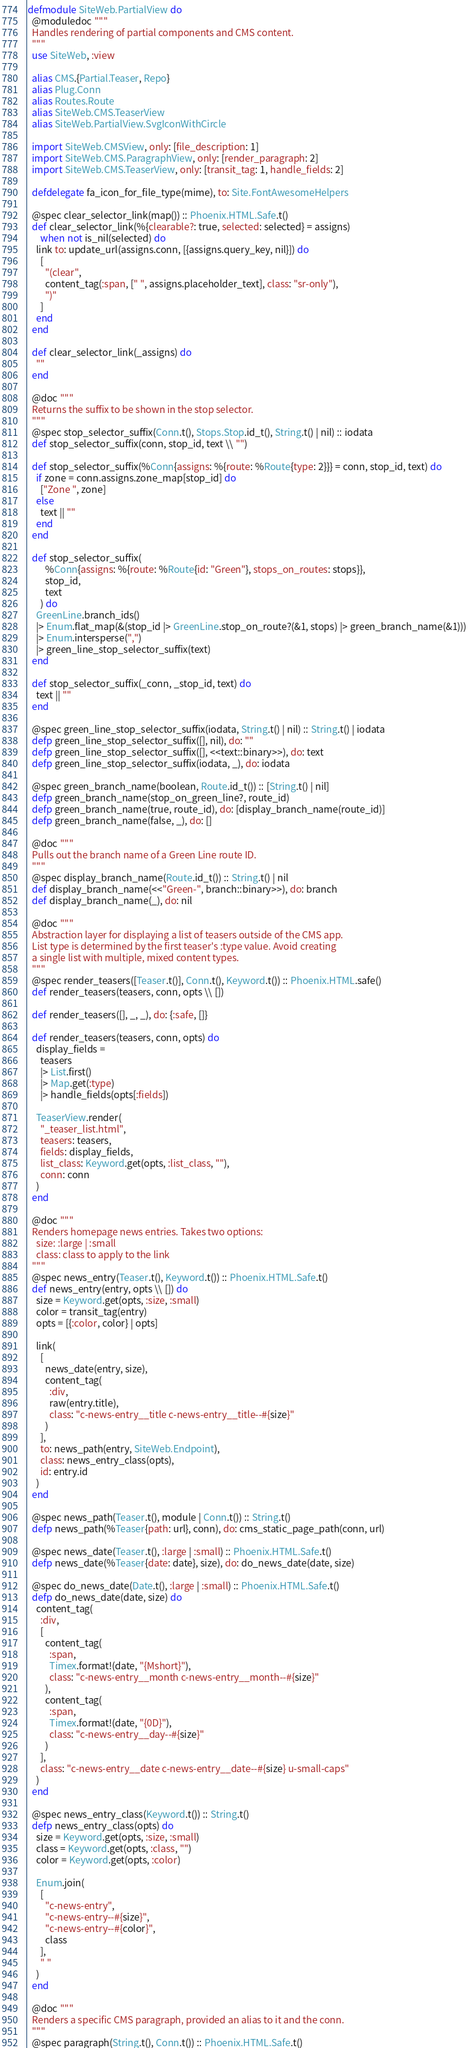<code> <loc_0><loc_0><loc_500><loc_500><_Elixir_>defmodule SiteWeb.PartialView do
  @moduledoc """
  Handles rendering of partial components and CMS content.
  """
  use SiteWeb, :view

  alias CMS.{Partial.Teaser, Repo}
  alias Plug.Conn
  alias Routes.Route
  alias SiteWeb.CMS.TeaserView
  alias SiteWeb.PartialView.SvgIconWithCircle

  import SiteWeb.CMSView, only: [file_description: 1]
  import SiteWeb.CMS.ParagraphView, only: [render_paragraph: 2]
  import SiteWeb.CMS.TeaserView, only: [transit_tag: 1, handle_fields: 2]

  defdelegate fa_icon_for_file_type(mime), to: Site.FontAwesomeHelpers

  @spec clear_selector_link(map()) :: Phoenix.HTML.Safe.t()
  def clear_selector_link(%{clearable?: true, selected: selected} = assigns)
      when not is_nil(selected) do
    link to: update_url(assigns.conn, [{assigns.query_key, nil}]) do
      [
        "(clear",
        content_tag(:span, [" ", assigns.placeholder_text], class: "sr-only"),
        ")"
      ]
    end
  end

  def clear_selector_link(_assigns) do
    ""
  end

  @doc """
  Returns the suffix to be shown in the stop selector.
  """
  @spec stop_selector_suffix(Conn.t(), Stops.Stop.id_t(), String.t() | nil) :: iodata
  def stop_selector_suffix(conn, stop_id, text \\ "")

  def stop_selector_suffix(%Conn{assigns: %{route: %Route{type: 2}}} = conn, stop_id, text) do
    if zone = conn.assigns.zone_map[stop_id] do
      ["Zone ", zone]
    else
      text || ""
    end
  end

  def stop_selector_suffix(
        %Conn{assigns: %{route: %Route{id: "Green"}, stops_on_routes: stops}},
        stop_id,
        text
      ) do
    GreenLine.branch_ids()
    |> Enum.flat_map(&(stop_id |> GreenLine.stop_on_route?(&1, stops) |> green_branch_name(&1)))
    |> Enum.intersperse(",")
    |> green_line_stop_selector_suffix(text)
  end

  def stop_selector_suffix(_conn, _stop_id, text) do
    text || ""
  end

  @spec green_line_stop_selector_suffix(iodata, String.t() | nil) :: String.t() | iodata
  defp green_line_stop_selector_suffix([], nil), do: ""
  defp green_line_stop_selector_suffix([], <<text::binary>>), do: text
  defp green_line_stop_selector_suffix(iodata, _), do: iodata

  @spec green_branch_name(boolean, Route.id_t()) :: [String.t() | nil]
  defp green_branch_name(stop_on_green_line?, route_id)
  defp green_branch_name(true, route_id), do: [display_branch_name(route_id)]
  defp green_branch_name(false, _), do: []

  @doc """
  Pulls out the branch name of a Green Line route ID.
  """
  @spec display_branch_name(Route.id_t()) :: String.t() | nil
  def display_branch_name(<<"Green-", branch::binary>>), do: branch
  def display_branch_name(_), do: nil

  @doc """
  Abstraction layer for displaying a list of teasers outside of the CMS app.
  List type is determined by the first teaser's :type value. Avoid creating
  a single list with multiple, mixed content types.
  """
  @spec render_teasers([Teaser.t()], Conn.t(), Keyword.t()) :: Phoenix.HTML.safe()
  def render_teasers(teasers, conn, opts \\ [])

  def render_teasers([], _, _), do: {:safe, []}

  def render_teasers(teasers, conn, opts) do
    display_fields =
      teasers
      |> List.first()
      |> Map.get(:type)
      |> handle_fields(opts[:fields])

    TeaserView.render(
      "_teaser_list.html",
      teasers: teasers,
      fields: display_fields,
      list_class: Keyword.get(opts, :list_class, ""),
      conn: conn
    )
  end

  @doc """
  Renders homepage news entries. Takes two options:
    size: :large | :small
    class: class to apply to the link
  """
  @spec news_entry(Teaser.t(), Keyword.t()) :: Phoenix.HTML.Safe.t()
  def news_entry(entry, opts \\ []) do
    size = Keyword.get(opts, :size, :small)
    color = transit_tag(entry)
    opts = [{:color, color} | opts]

    link(
      [
        news_date(entry, size),
        content_tag(
          :div,
          raw(entry.title),
          class: "c-news-entry__title c-news-entry__title--#{size}"
        )
      ],
      to: news_path(entry, SiteWeb.Endpoint),
      class: news_entry_class(opts),
      id: entry.id
    )
  end

  @spec news_path(Teaser.t(), module | Conn.t()) :: String.t()
  defp news_path(%Teaser{path: url}, conn), do: cms_static_page_path(conn, url)

  @spec news_date(Teaser.t(), :large | :small) :: Phoenix.HTML.Safe.t()
  defp news_date(%Teaser{date: date}, size), do: do_news_date(date, size)

  @spec do_news_date(Date.t(), :large | :small) :: Phoenix.HTML.Safe.t()
  defp do_news_date(date, size) do
    content_tag(
      :div,
      [
        content_tag(
          :span,
          Timex.format!(date, "{Mshort}"),
          class: "c-news-entry__month c-news-entry__month--#{size}"
        ),
        content_tag(
          :span,
          Timex.format!(date, "{0D}"),
          class: "c-news-entry__day--#{size}"
        )
      ],
      class: "c-news-entry__date c-news-entry__date--#{size} u-small-caps"
    )
  end

  @spec news_entry_class(Keyword.t()) :: String.t()
  defp news_entry_class(opts) do
    size = Keyword.get(opts, :size, :small)
    class = Keyword.get(opts, :class, "")
    color = Keyword.get(opts, :color)

    Enum.join(
      [
        "c-news-entry",
        "c-news-entry--#{size}",
        "c-news-entry--#{color}",
        class
      ],
      " "
    )
  end

  @doc """
  Renders a specific CMS paragraph, provided an alias to it and the conn.
  """
  @spec paragraph(String.t(), Conn.t()) :: Phoenix.HTML.Safe.t()</code> 